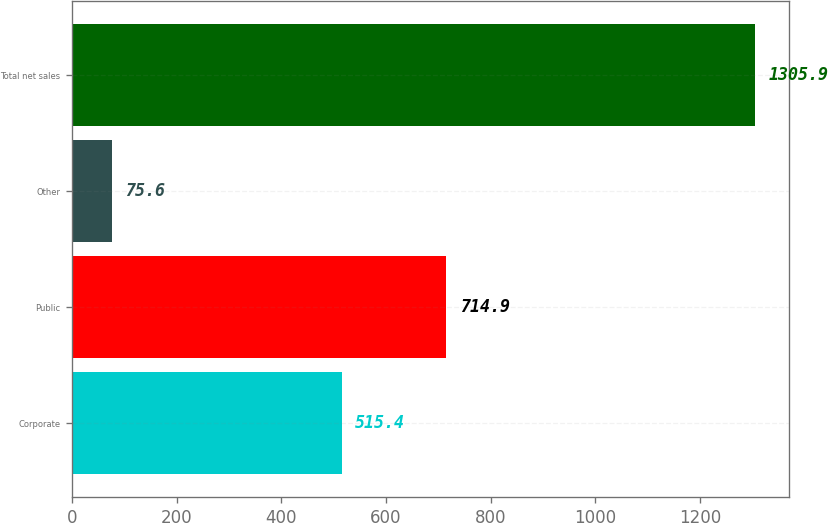Convert chart. <chart><loc_0><loc_0><loc_500><loc_500><bar_chart><fcel>Corporate<fcel>Public<fcel>Other<fcel>Total net sales<nl><fcel>515.4<fcel>714.9<fcel>75.6<fcel>1305.9<nl></chart> 